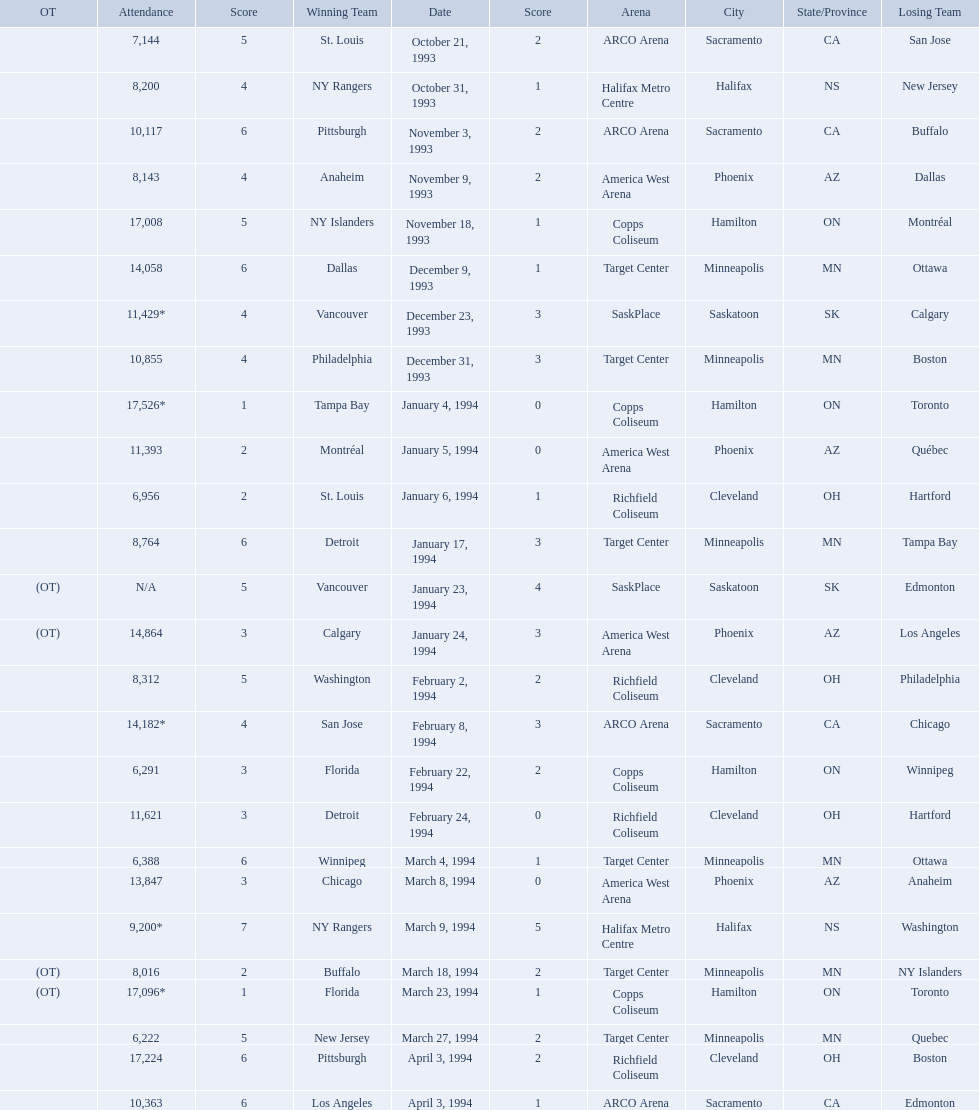When were the games played? October 21, 1993, October 31, 1993, November 3, 1993, November 9, 1993, November 18, 1993, December 9, 1993, December 23, 1993, December 31, 1993, January 4, 1994, January 5, 1994, January 6, 1994, January 17, 1994, January 23, 1994, January 24, 1994, February 2, 1994, February 8, 1994, February 22, 1994, February 24, 1994, March 4, 1994, March 8, 1994, March 9, 1994, March 18, 1994, March 23, 1994, March 27, 1994, April 3, 1994, April 3, 1994. What was the attendance for those games? 7,144, 8,200, 10,117, 8,143, 17,008, 14,058, 11,429*, 10,855, 17,526*, 11,393, 6,956, 8,764, N/A, 14,864, 8,312, 14,182*, 6,291, 11,621, 6,388, 13,847, 9,200*, 8,016, 17,096*, 6,222, 17,224, 10,363. Which date had the highest attendance? January 4, 1994. 